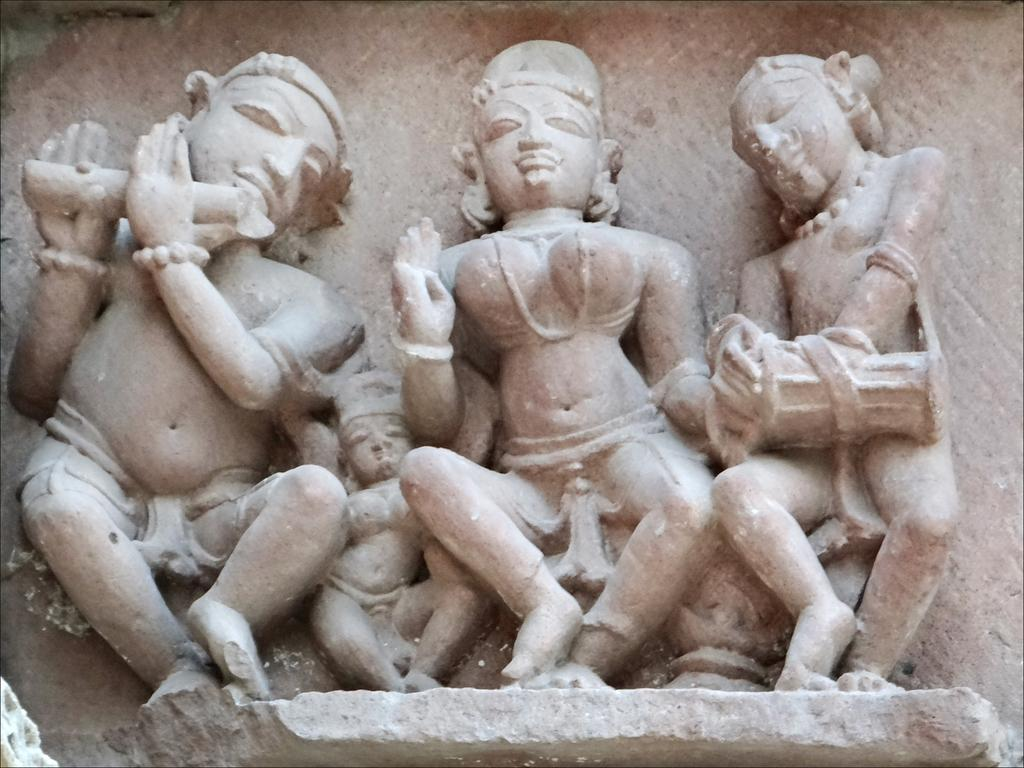What is present on the wall in the image? There are four sculptures on the wall in the image. What type of rhythm can be heard coming from the sculptures in the image? There is no indication in the image that the sculptures are producing any sound or rhythm. 